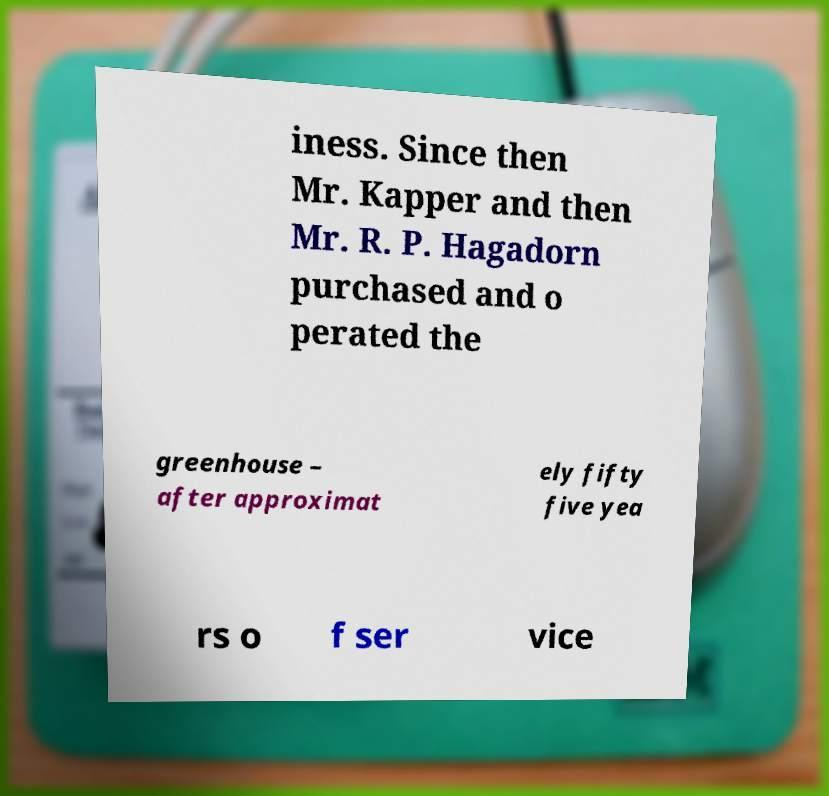Please read and relay the text visible in this image. What does it say? iness. Since then Mr. Kapper and then Mr. R. P. Hagadorn purchased and o perated the greenhouse – after approximat ely fifty five yea rs o f ser vice 